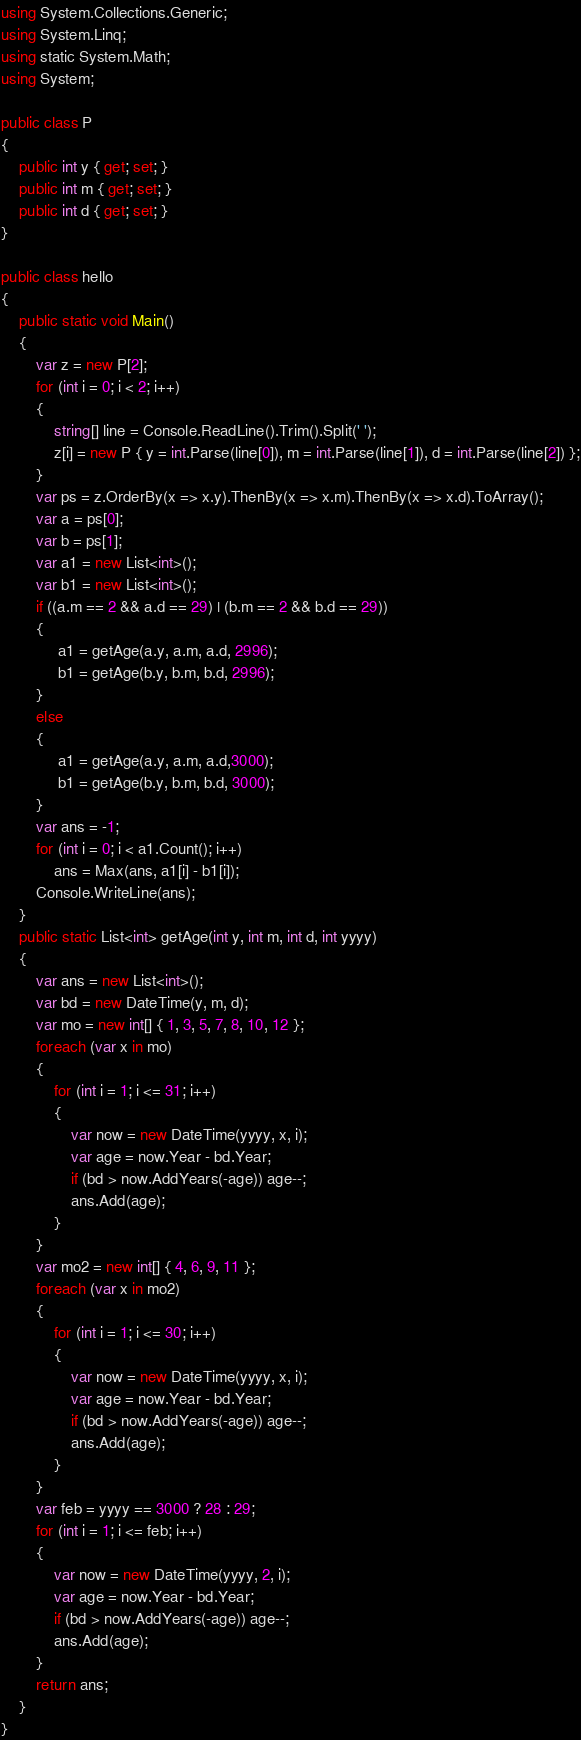<code> <loc_0><loc_0><loc_500><loc_500><_C#_>using System.Collections.Generic;
using System.Linq;
using static System.Math;
using System;

public class P
{
    public int y { get; set; }
    public int m { get; set; }
    public int d { get; set; }
}

public class hello
{
    public static void Main()
    {
        var z = new P[2];
        for (int i = 0; i < 2; i++)
        {
            string[] line = Console.ReadLine().Trim().Split(' ');
            z[i] = new P { y = int.Parse(line[0]), m = int.Parse(line[1]), d = int.Parse(line[2]) };
        }
        var ps = z.OrderBy(x => x.y).ThenBy(x => x.m).ThenBy(x => x.d).ToArray();
        var a = ps[0];
        var b = ps[1];
        var a1 = new List<int>();
        var b1 = new List<int>();
        if ((a.m == 2 && a.d == 29) | (b.m == 2 && b.d == 29))
        {
             a1 = getAge(a.y, a.m, a.d, 2996);
             b1 = getAge(b.y, b.m, b.d, 2996);
        }
        else
        {
             a1 = getAge(a.y, a.m, a.d,3000);
             b1 = getAge(b.y, b.m, b.d, 3000);
        }
        var ans = -1;
        for (int i = 0; i < a1.Count(); i++)
            ans = Max(ans, a1[i] - b1[i]);
        Console.WriteLine(ans);
    }
    public static List<int> getAge(int y, int m, int d, int yyyy)
    {
        var ans = new List<int>();
        var bd = new DateTime(y, m, d);
        var mo = new int[] { 1, 3, 5, 7, 8, 10, 12 };
        foreach (var x in mo)
        {
            for (int i = 1; i <= 31; i++)
            {
                var now = new DateTime(yyyy, x, i);
                var age = now.Year - bd.Year;
                if (bd > now.AddYears(-age)) age--;
                ans.Add(age);
            }
        }
        var mo2 = new int[] { 4, 6, 9, 11 };
        foreach (var x in mo2)
        {
            for (int i = 1; i <= 30; i++)
            {
                var now = new DateTime(yyyy, x, i);
                var age = now.Year - bd.Year;
                if (bd > now.AddYears(-age)) age--;
                ans.Add(age);
            }
        }
        var feb = yyyy == 3000 ? 28 : 29;
        for (int i = 1; i <= feb; i++)
        {
            var now = new DateTime(yyyy, 2, i);
            var age = now.Year - bd.Year;
            if (bd > now.AddYears(-age)) age--;
            ans.Add(age);
        }
        return ans;
    }
}



</code> 